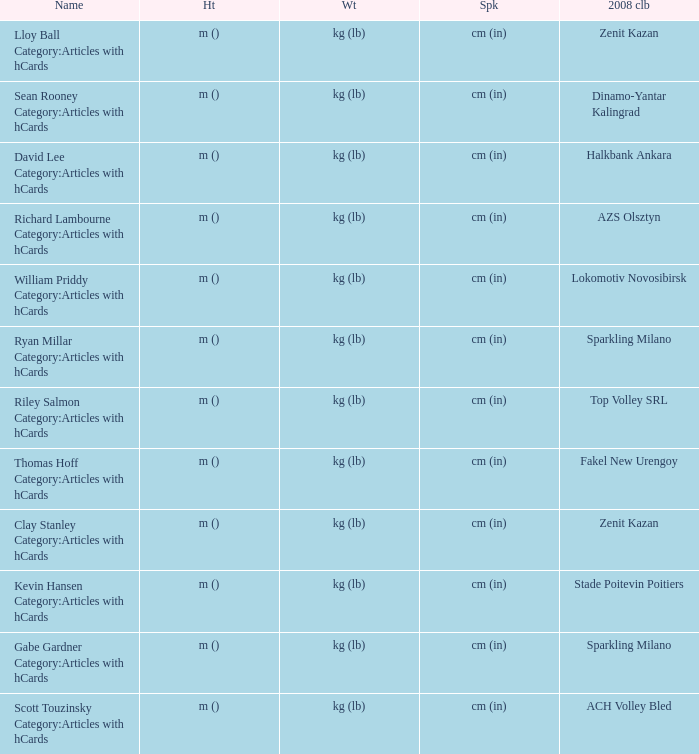What is the name for the 2008 club of Azs olsztyn? Richard Lambourne Category:Articles with hCards. Write the full table. {'header': ['Name', 'Ht', 'Wt', 'Spk', '2008 clb'], 'rows': [['Lloy Ball Category:Articles with hCards', 'm ()', 'kg (lb)', 'cm (in)', 'Zenit Kazan'], ['Sean Rooney Category:Articles with hCards', 'm ()', 'kg (lb)', 'cm (in)', 'Dinamo-Yantar Kalingrad'], ['David Lee Category:Articles with hCards', 'm ()', 'kg (lb)', 'cm (in)', 'Halkbank Ankara'], ['Richard Lambourne Category:Articles with hCards', 'm ()', 'kg (lb)', 'cm (in)', 'AZS Olsztyn'], ['William Priddy Category:Articles with hCards', 'm ()', 'kg (lb)', 'cm (in)', 'Lokomotiv Novosibirsk'], ['Ryan Millar Category:Articles with hCards', 'm ()', 'kg (lb)', 'cm (in)', 'Sparkling Milano'], ['Riley Salmon Category:Articles with hCards', 'm ()', 'kg (lb)', 'cm (in)', 'Top Volley SRL'], ['Thomas Hoff Category:Articles with hCards', 'm ()', 'kg (lb)', 'cm (in)', 'Fakel New Urengoy'], ['Clay Stanley Category:Articles with hCards', 'm ()', 'kg (lb)', 'cm (in)', 'Zenit Kazan'], ['Kevin Hansen Category:Articles with hCards', 'm ()', 'kg (lb)', 'cm (in)', 'Stade Poitevin Poitiers'], ['Gabe Gardner Category:Articles with hCards', 'm ()', 'kg (lb)', 'cm (in)', 'Sparkling Milano'], ['Scott Touzinsky Category:Articles with hCards', 'm ()', 'kg (lb)', 'cm (in)', 'ACH Volley Bled']]} 